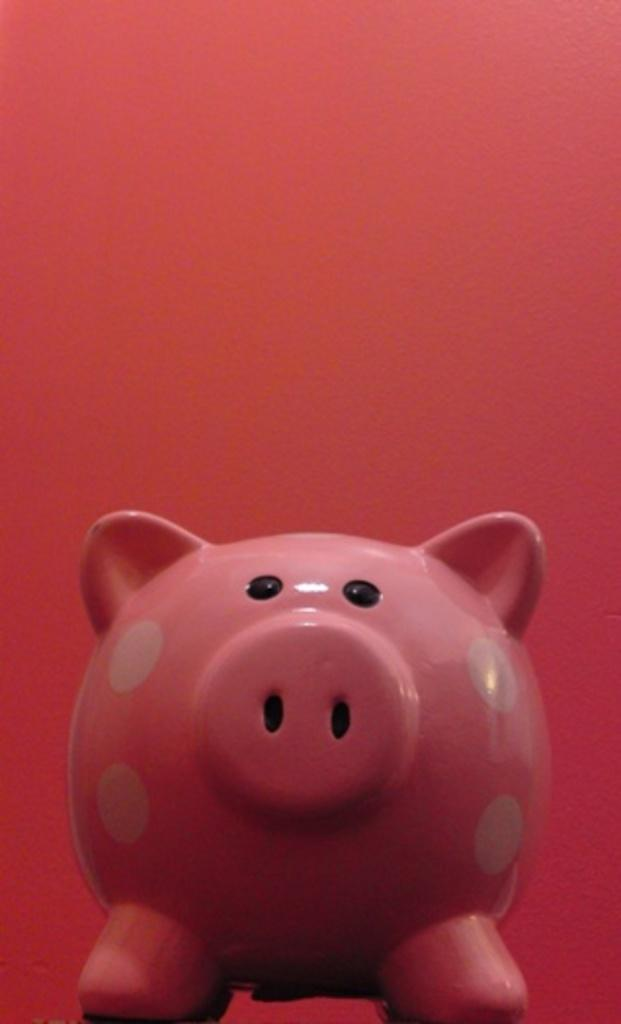What is the color of the piggy in the image? The piggy in the image is pink in color. What can be said about the background of the image? The background of the image is red in color. What size badge is the piggy wearing in the image? The piggy in the image is not wearing a badge, so it cannot be determined what size badge it might be wearing. What type of attraction is the piggy associated with in the image? The piggy in the image is not associated with any attraction; it is simply a pink piggy in the image. 